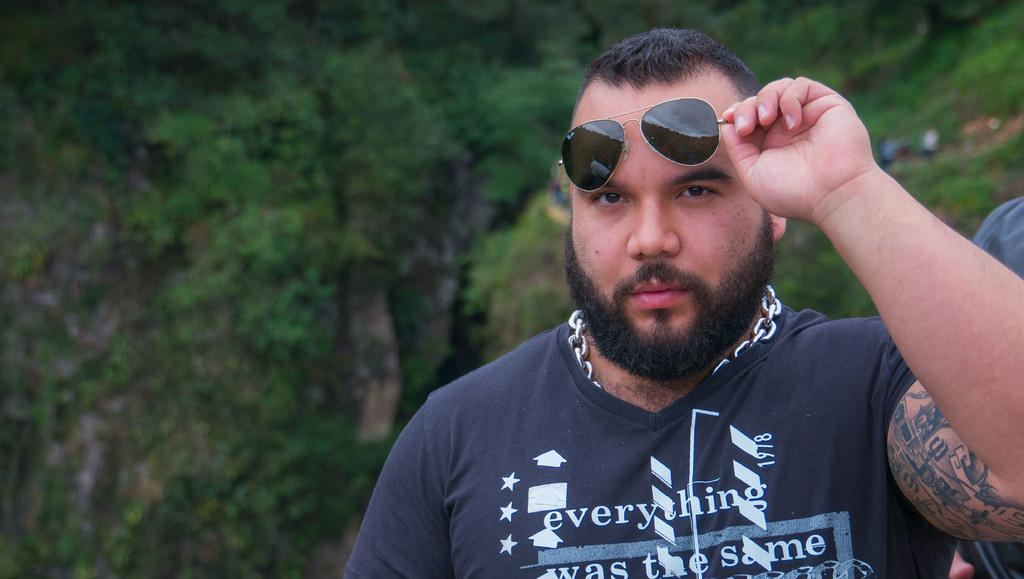What is the man in the image doing? There is a man standing in the image. What is the man holding in his hand? The man is holding sunglasses in his hand. What accessory is the man wearing around his neck? The man is wearing an ornament around his neck. What type of vegetation can be seen in the image? There are trees visible in the image. How many men are present in the image? There are two men standing in the image. What type of doctor can be seen treating the man's broken arm in the image? There is no doctor or broken arm present in the image. How many bananas is the man holding in the image? The man is not holding any bananas in the image; he is holding sunglasses. 